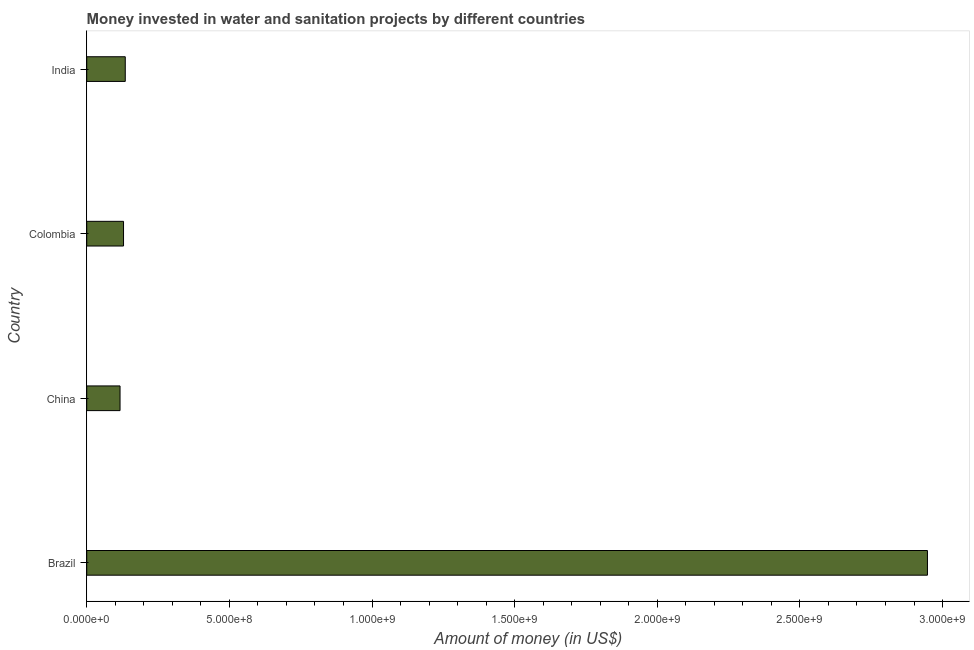Does the graph contain grids?
Ensure brevity in your answer.  No. What is the title of the graph?
Ensure brevity in your answer.  Money invested in water and sanitation projects by different countries. What is the label or title of the X-axis?
Ensure brevity in your answer.  Amount of money (in US$). What is the label or title of the Y-axis?
Offer a very short reply. Country. What is the investment in Colombia?
Provide a succinct answer. 1.29e+08. Across all countries, what is the maximum investment?
Your answer should be very brief. 2.95e+09. Across all countries, what is the minimum investment?
Offer a very short reply. 1.17e+08. What is the sum of the investment?
Ensure brevity in your answer.  3.33e+09. What is the difference between the investment in Brazil and Colombia?
Offer a very short reply. 2.82e+09. What is the average investment per country?
Your answer should be compact. 8.32e+08. What is the median investment?
Provide a short and direct response. 1.32e+08. What is the ratio of the investment in Brazil to that in India?
Offer a very short reply. 21.81. Is the difference between the investment in China and Colombia greater than the difference between any two countries?
Your answer should be compact. No. What is the difference between the highest and the second highest investment?
Make the answer very short. 2.81e+09. Is the sum of the investment in China and India greater than the maximum investment across all countries?
Provide a short and direct response. No. What is the difference between the highest and the lowest investment?
Make the answer very short. 2.83e+09. What is the Amount of money (in US$) of Brazil?
Ensure brevity in your answer.  2.95e+09. What is the Amount of money (in US$) in China?
Your response must be concise. 1.17e+08. What is the Amount of money (in US$) in Colombia?
Your answer should be compact. 1.29e+08. What is the Amount of money (in US$) of India?
Offer a terse response. 1.35e+08. What is the difference between the Amount of money (in US$) in Brazil and China?
Offer a very short reply. 2.83e+09. What is the difference between the Amount of money (in US$) in Brazil and Colombia?
Give a very brief answer. 2.82e+09. What is the difference between the Amount of money (in US$) in Brazil and India?
Keep it short and to the point. 2.81e+09. What is the difference between the Amount of money (in US$) in China and Colombia?
Offer a very short reply. -1.22e+07. What is the difference between the Amount of money (in US$) in China and India?
Your answer should be compact. -1.83e+07. What is the difference between the Amount of money (in US$) in Colombia and India?
Your answer should be compact. -6.10e+06. What is the ratio of the Amount of money (in US$) in Brazil to that in China?
Ensure brevity in your answer.  25.24. What is the ratio of the Amount of money (in US$) in Brazil to that in Colombia?
Make the answer very short. 22.85. What is the ratio of the Amount of money (in US$) in Brazil to that in India?
Give a very brief answer. 21.81. What is the ratio of the Amount of money (in US$) in China to that in Colombia?
Your answer should be compact. 0.91. What is the ratio of the Amount of money (in US$) in China to that in India?
Your answer should be compact. 0.86. What is the ratio of the Amount of money (in US$) in Colombia to that in India?
Provide a succinct answer. 0.95. 